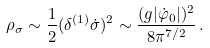<formula> <loc_0><loc_0><loc_500><loc_500>\rho _ { \sigma } \sim \frac { 1 } { 2 } ( \delta ^ { ( 1 ) } \dot { \sigma } ) ^ { 2 } \sim \frac { ( g | \dot { \varphi } _ { 0 } | ) ^ { 2 } } { 8 \pi ^ { 7 / 2 } } \, .</formula> 